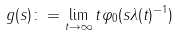<formula> <loc_0><loc_0><loc_500><loc_500>g ( s ) \colon = \lim _ { t \rightarrow \infty } t \varphi _ { 0 } ( s \lambda ( t ) ^ { - 1 } )</formula> 